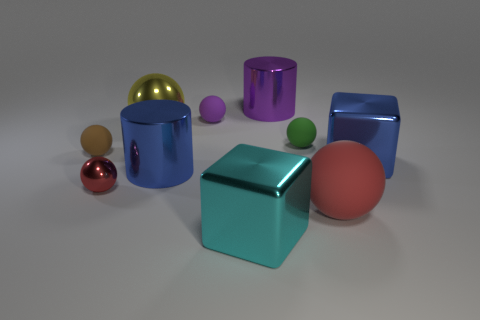What number of yellow things are either tiny things or big metallic objects?
Provide a succinct answer. 1. There is a cube left of the block on the right side of the large purple thing; are there any red rubber balls left of it?
Make the answer very short. No. Is there any other thing that is the same size as the yellow shiny sphere?
Keep it short and to the point. Yes. Is the large matte thing the same color as the tiny shiny sphere?
Provide a short and direct response. Yes. What color is the big metal cube behind the big ball on the right side of the big yellow shiny object?
Ensure brevity in your answer.  Blue. What number of big objects are either yellow objects or matte cubes?
Your answer should be very brief. 1. The ball that is both in front of the small brown sphere and behind the big red matte sphere is what color?
Your answer should be compact. Red. Is the material of the tiny red sphere the same as the large cyan cube?
Your answer should be compact. Yes. What shape is the tiny brown rubber object?
Give a very brief answer. Sphere. How many big balls are behind the metal cube to the right of the large cylinder behind the tiny brown matte sphere?
Give a very brief answer. 1. 